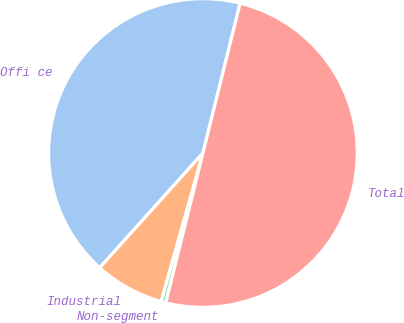<chart> <loc_0><loc_0><loc_500><loc_500><pie_chart><fcel>Offi ce<fcel>Industrial<fcel>Non-segment<fcel>Total<nl><fcel>42.21%<fcel>7.3%<fcel>0.49%<fcel>50.0%<nl></chart> 